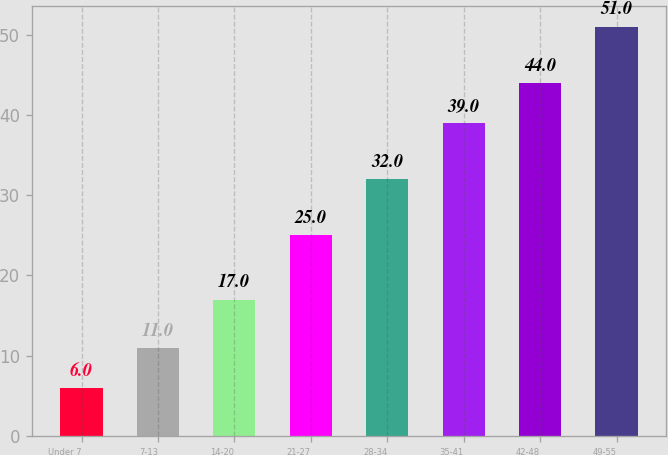<chart> <loc_0><loc_0><loc_500><loc_500><bar_chart><fcel>Under 7<fcel>7-13<fcel>14-20<fcel>21-27<fcel>28-34<fcel>35-41<fcel>42-48<fcel>49-55<nl><fcel>6<fcel>11<fcel>17<fcel>25<fcel>32<fcel>39<fcel>44<fcel>51<nl></chart> 